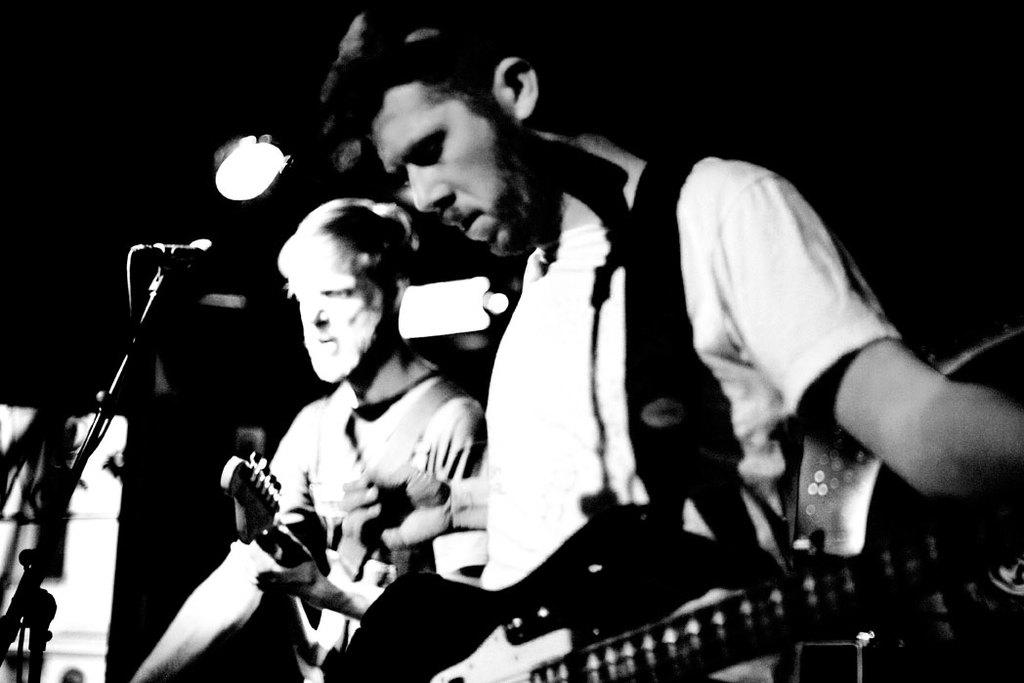What are the two people in the image doing? The two people in the image are standing and playing guitars. What object is present to amplify their voices? A microphone is present in the image. How is the microphone supported in the image? A microphone stand is visible in the image. What can be seen in the background of the image? There is a focus light in the background of the image. What type of cheese is being served in the image? There is no cheese present in the image. What is the weather like in the image? The image does not provide any information about the weather. 